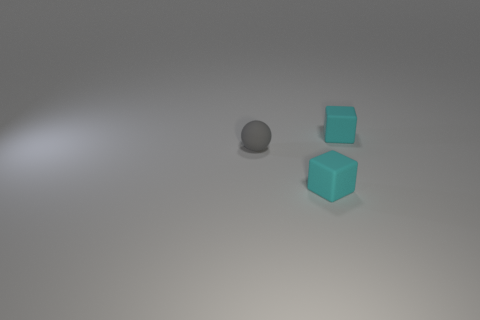Add 3 gray cylinders. How many objects exist? 6 Subtract all cubes. How many objects are left? 1 Subtract 0 yellow cylinders. How many objects are left? 3 Subtract all cyan matte cubes. Subtract all gray rubber spheres. How many objects are left? 0 Add 2 small matte things. How many small matte things are left? 5 Add 3 large brown rubber objects. How many large brown rubber objects exist? 3 